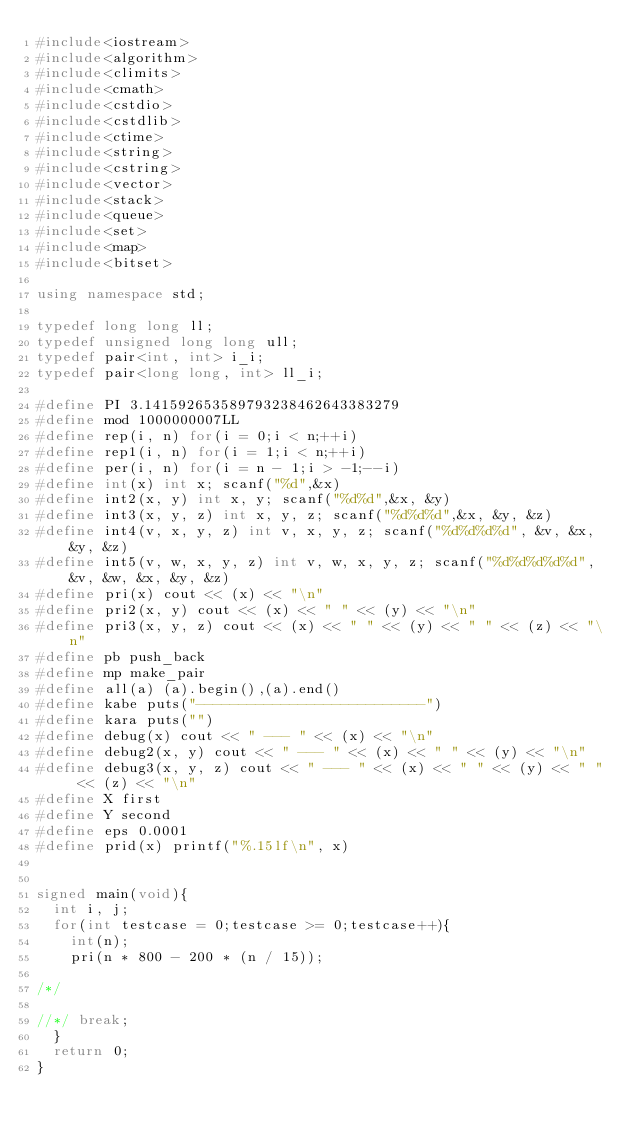Convert code to text. <code><loc_0><loc_0><loc_500><loc_500><_C++_>#include<iostream>
#include<algorithm>
#include<climits>
#include<cmath>
#include<cstdio>
#include<cstdlib>
#include<ctime>
#include<string>
#include<cstring>
#include<vector>
#include<stack>
#include<queue>
#include<set>
#include<map>
#include<bitset>

using namespace std;

typedef long long ll;
typedef unsigned long long ull;
typedef pair<int, int> i_i;
typedef pair<long long, int> ll_i;

#define PI 3.141592653589793238462643383279
#define mod 1000000007LL
#define rep(i, n) for(i = 0;i < n;++i)
#define rep1(i, n) for(i = 1;i < n;++i)
#define per(i, n) for(i = n - 1;i > -1;--i)
#define int(x) int x; scanf("%d",&x)
#define int2(x, y) int x, y; scanf("%d%d",&x, &y)
#define int3(x, y, z) int x, y, z; scanf("%d%d%d",&x, &y, &z)
#define int4(v, x, y, z) int v, x, y, z; scanf("%d%d%d%d", &v, &x, &y, &z)
#define int5(v, w, x, y, z) int v, w, x, y, z; scanf("%d%d%d%d%d", &v, &w, &x, &y, &z)
#define pri(x) cout << (x) << "\n"
#define pri2(x, y) cout << (x) << " " << (y) << "\n"
#define pri3(x, y, z) cout << (x) << " " << (y) << " " << (z) << "\n"
#define pb push_back
#define mp make_pair
#define all(a) (a).begin(),(a).end()
#define kabe puts("---------------------------")
#define kara puts("")
#define debug(x) cout << " --- " << (x) << "\n"
#define debug2(x, y) cout << " --- " << (x) << " " << (y) << "\n"
#define debug3(x, y, z) cout << " --- " << (x) << " " << (y) << " " << (z) << "\n"
#define X first
#define Y second
#define eps 0.0001
#define prid(x) printf("%.15lf\n", x)


signed main(void){
  int i, j;
  for(int testcase = 0;testcase >= 0;testcase++){
    int(n);
    pri(n * 800 - 200 * (n / 15));

/*/

//*/ break;
  }
  return 0;
}
</code> 